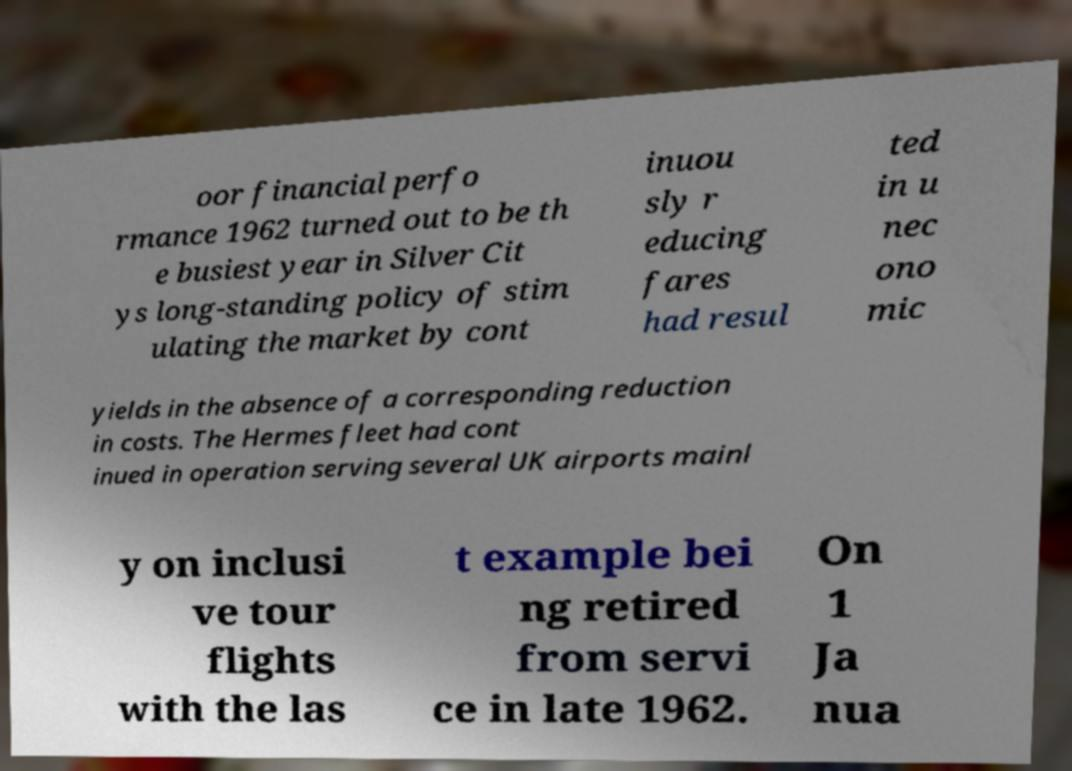There's text embedded in this image that I need extracted. Can you transcribe it verbatim? oor financial perfo rmance 1962 turned out to be th e busiest year in Silver Cit ys long-standing policy of stim ulating the market by cont inuou sly r educing fares had resul ted in u nec ono mic yields in the absence of a corresponding reduction in costs. The Hermes fleet had cont inued in operation serving several UK airports mainl y on inclusi ve tour flights with the las t example bei ng retired from servi ce in late 1962. On 1 Ja nua 